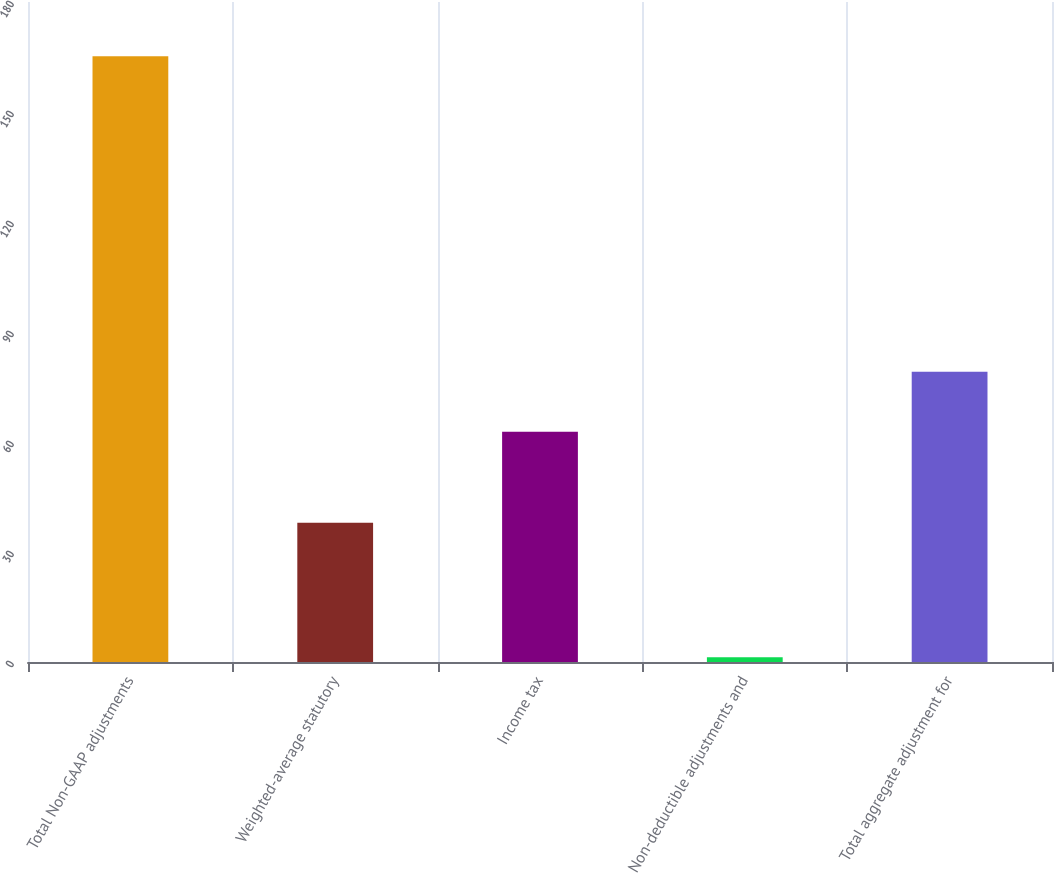Convert chart. <chart><loc_0><loc_0><loc_500><loc_500><bar_chart><fcel>Total Non-GAAP adjustments<fcel>Weighted-average statutory<fcel>Income tax<fcel>Non-deductible adjustments and<fcel>Total aggregate adjustment for<nl><fcel>165.2<fcel>38<fcel>62.8<fcel>1.3<fcel>79.19<nl></chart> 